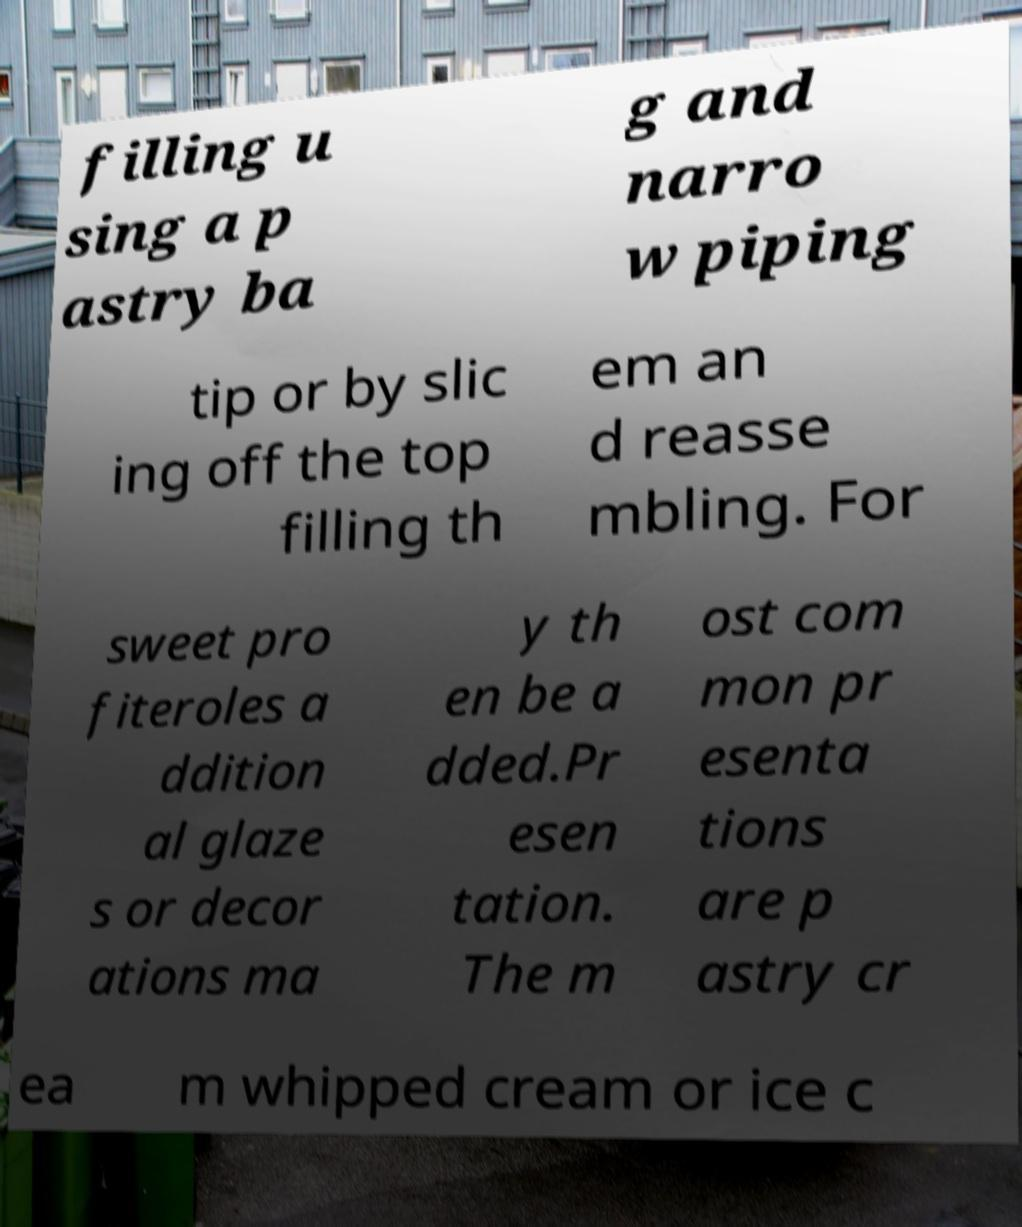I need the written content from this picture converted into text. Can you do that? filling u sing a p astry ba g and narro w piping tip or by slic ing off the top filling th em an d reasse mbling. For sweet pro fiteroles a ddition al glaze s or decor ations ma y th en be a dded.Pr esen tation. The m ost com mon pr esenta tions are p astry cr ea m whipped cream or ice c 